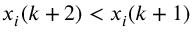Convert formula to latex. <formula><loc_0><loc_0><loc_500><loc_500>x _ { i } ( k + 2 ) < x _ { i } ( k + 1 )</formula> 